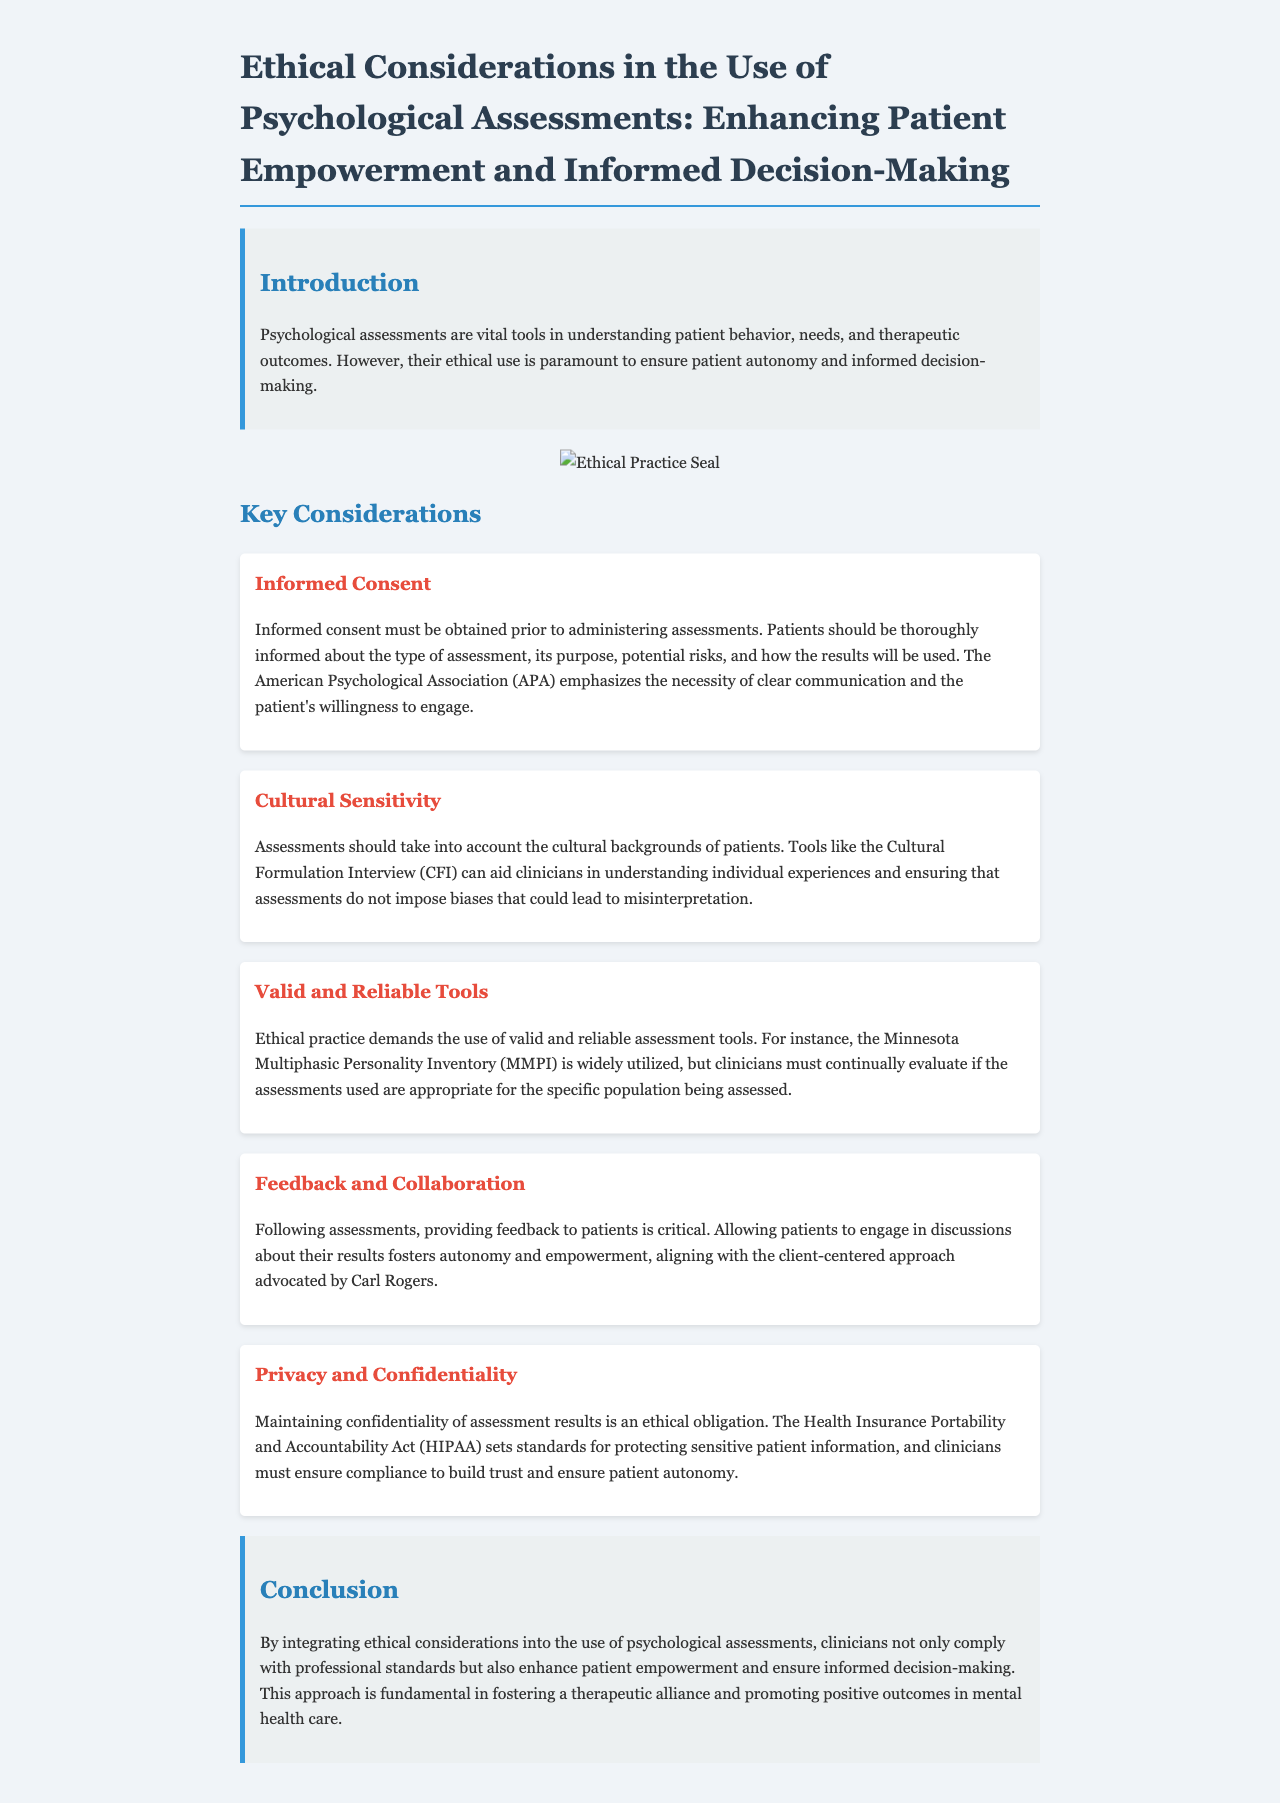what is the title of the report? The title of the report is provided in the document heading.
Answer: Ethical Considerations in the Use of Psychological Assessments: Enhancing Patient Empowerment and Informed Decision-Making what is one of the key considerations mentioned in the report? The report outlines several key considerations, including informed consent, which is highlighted in a dedicated section.
Answer: Informed Consent what is the ethical obligation related to patient information? The document emphasizes the importance of maintaining patient information confidentiality, as outlined in the relevant section.
Answer: Privacy and Confidentiality which assessment tool is mentioned as widely utilized? The report references a specific assessment tool known for its widespread use in psychological evaluation.
Answer: Minnesota Multiphasic Personality Inventory what action should be taken following assessments according to the document? The report suggests a critical step in the process after assessments, which promotes patient involvement.
Answer: Providing feedback how does the report suggest clinicians should handle cultural backgrounds? The document advises on how to respect patients' backgrounds to ensure assessments are appropriate, mentioning a particular tool.
Answer: Cultural Formulation Interview what is the primary goal of integrating ethical considerations in psychological assessments? The report outlines a fundamental aim of integrating specific ethical practices in assessments to achieve a particular outcome.
Answer: Patient empowerment what standard is referenced for protecting sensitive patient information? The document cites a specific act that sets standards to ensure patient information confidentiality.
Answer: Health Insurance Portability and Accountability Act what does the report emphasize about communication with patients? The text highlights an important aspect of communication that ensures patients are fully informed prior to assessments.
Answer: Clear communication 